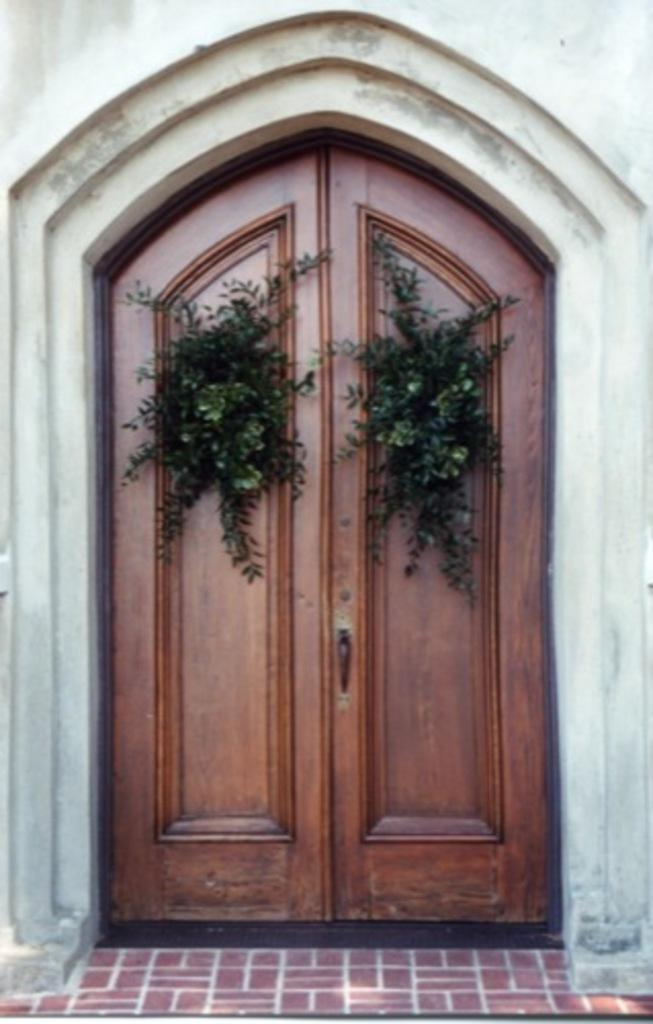What type of structure is present in the image? There is a building in the image. What can be seen in the center of the image? There are plants in the center of the image. How are the plants positioned in the image? The plants are placed on a wooden door. What part of the image shows the ground or surface on which the building stands? The floor is visible at the bottom of the image. What type of engine is powering the building in the image? There is no engine present in the image, as buildings are not powered by engines. 